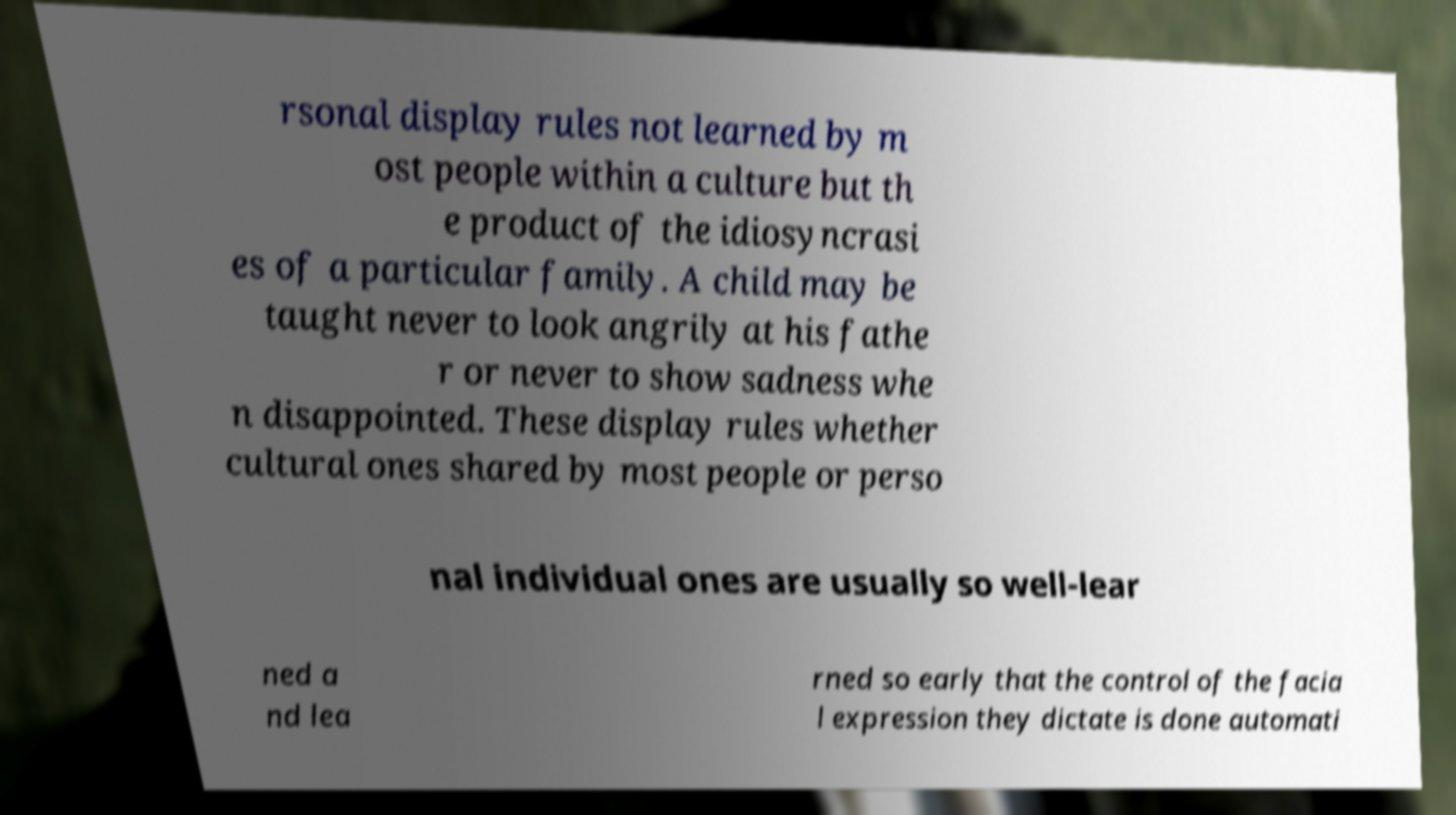There's text embedded in this image that I need extracted. Can you transcribe it verbatim? rsonal display rules not learned by m ost people within a culture but th e product of the idiosyncrasi es of a particular family. A child may be taught never to look angrily at his fathe r or never to show sadness whe n disappointed. These display rules whether cultural ones shared by most people or perso nal individual ones are usually so well-lear ned a nd lea rned so early that the control of the facia l expression they dictate is done automati 